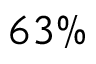<formula> <loc_0><loc_0><loc_500><loc_500>6 3 \%</formula> 